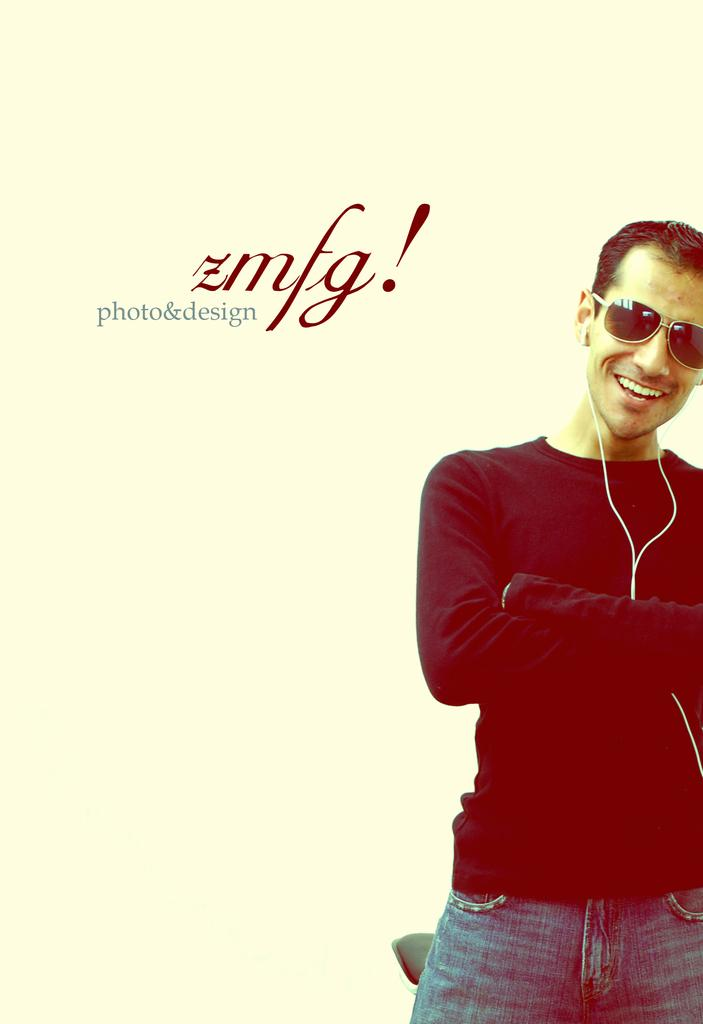What is the main subject of the photo poster in the image? The photo poster features a boy. What is the boy wearing in the photo? The boy is wearing a black t-shirt. What is the boy doing in the photo? The boy is standing in the photo. What expression does the boy have in the photo? The boy is smiling in the photo. How many pizzas can be seen on the boy's head in the photo? There are no pizzas visible on the boy's head in the photo. Is the boy sleeping in the photo? No, the boy is not sleeping in the photo; he is standing and smiling. --- Facts: 1. There is a car in the image. 2. The car is red. 3. The car has four wheels. 4. There are people sitting inside the car. 5. The car has a sunroof. Absurd Topics: parrot, sandcastle, ocean Conversation: What is the main subject of the image? The main subject of the image is a car. What color is the car? The car is red. How many wheels does the car have? The car has four wheels. What can be seen inside the car? There are people sitting inside the car. What additional feature does the car have? The car has a sunroof. Reasoning: Let's think step by step in order to produce the conversation. We start by identifying the main subject of the image, which is the car. Then, we describe the car's color, number of wheels, and the presence of people inside the car. Finally, we mention the car's additional feature, which is the sunroof. Absurd Question/Answer: Can you see a parrot sitting on the car's hood in the image? No, there is no parrot visible on the car's hood in the image. Is the car parked near an ocean in the image? There is no indication of an ocean or any body of water in the image. --- Facts: 1. There is a dog in the image. 2. The dog is brown. 3. The dog is sitting on a rug. 4. The rug has a pattern. 5. There is a fireplace in the background. Absurd Topics: bicycle, rainbow, piano Conversation: What is the main subject of the image? The main subject of the image is a dog. What color is the dog? The dog is brown. What is the dog sitting on in the image? The dog is sitting on a rug. Can you describe the rug in the image? The rug has a pattern. What can be seen in the background of the image? There is a fireplace in the background. Reasoning: Let's think step by step in order to produce the conversation. We start by identifying the main subject 